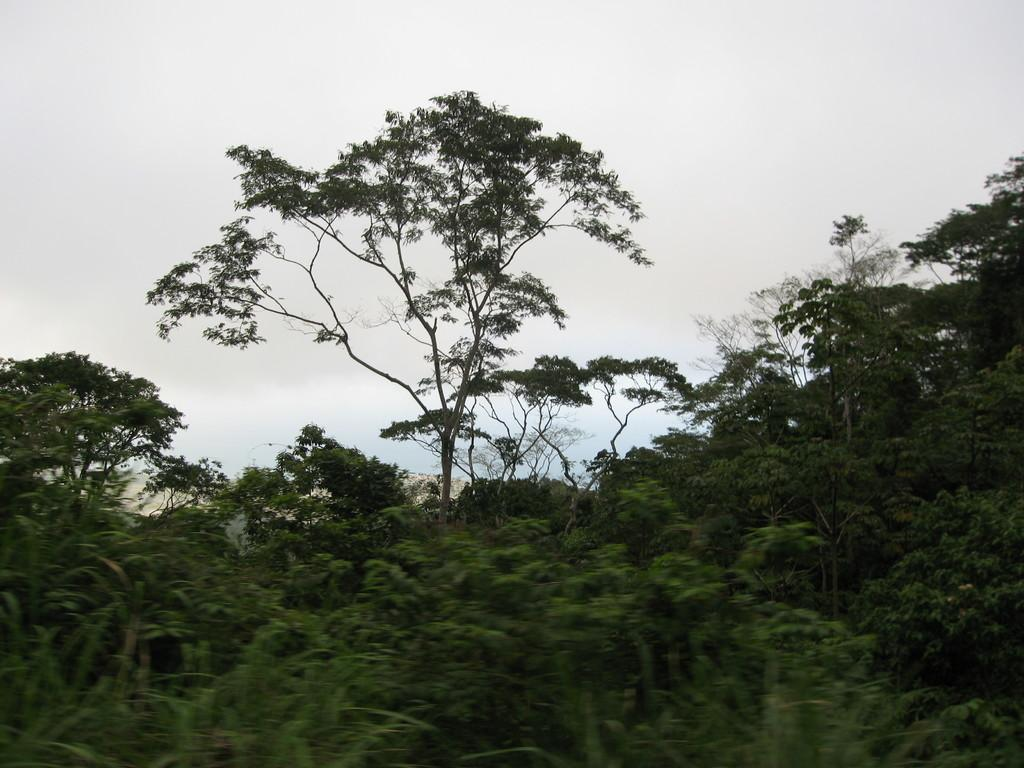What type of vegetation can be seen in the image? There are trees in the image. What geographical features are present in the image? There are hills in the image. What is visible at the top of the image? The sky is visible at the top of the image. What time of day is it in the image? The time of day cannot be determined from the image, as there are no specific indicators of time. Can you see the aunt in the image? There is no mention of an aunt in the image, so it cannot be determined if she is present. 